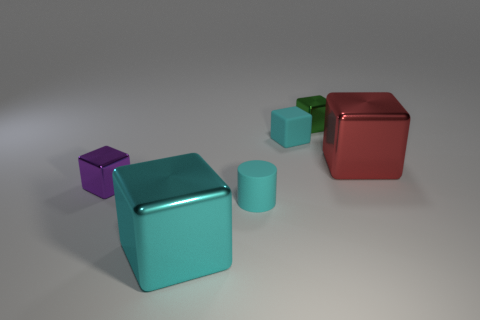Is the color of the tiny cylinder the same as the small rubber cube?
Keep it short and to the point. Yes. There is a large cyan thing that is the same shape as the green object; what is its material?
Give a very brief answer. Metal. What number of large cyan rubber blocks are there?
Provide a succinct answer. 0. What is the material of the tiny cyan thing behind the purple object?
Your answer should be compact. Rubber. There is a red object; are there any rubber things to the left of it?
Offer a terse response. Yes. Is the green metallic thing the same size as the purple object?
Ensure brevity in your answer.  Yes. What number of tiny purple blocks have the same material as the small cyan cube?
Provide a succinct answer. 0. There is a cyan metal object in front of the small cube left of the small cylinder; how big is it?
Your response must be concise. Large. What is the color of the cube that is to the left of the tiny cylinder and behind the tiny cylinder?
Make the answer very short. Purple. Do the purple thing and the small green object have the same shape?
Offer a very short reply. Yes. 